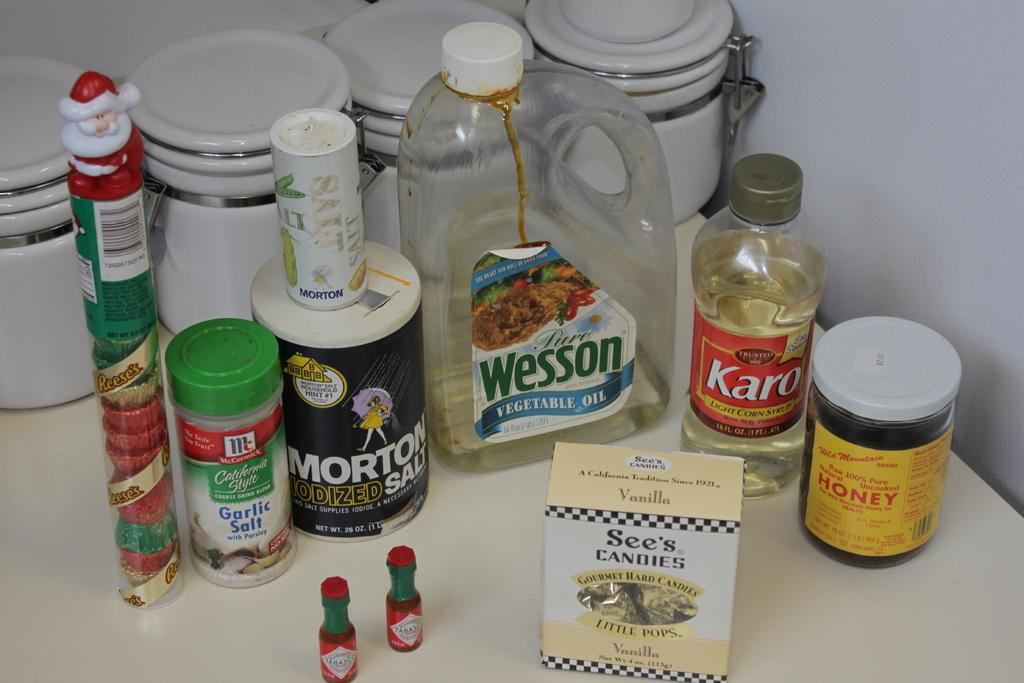<image>
Give a short and clear explanation of the subsequent image. a bottle that has the word Wesson on it 